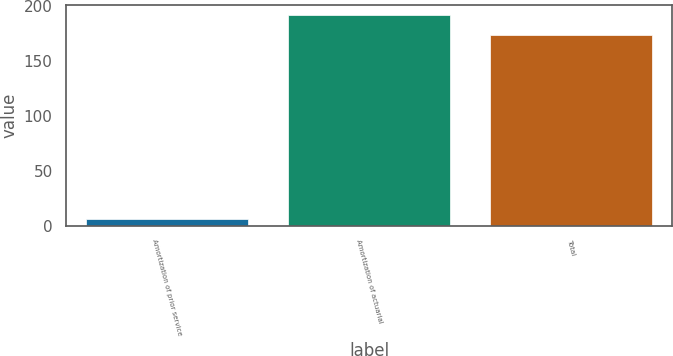Convert chart. <chart><loc_0><loc_0><loc_500><loc_500><bar_chart><fcel>Amortization of prior service<fcel>Amortization of actuarial<fcel>Total<nl><fcel>6<fcel>191.4<fcel>174<nl></chart> 